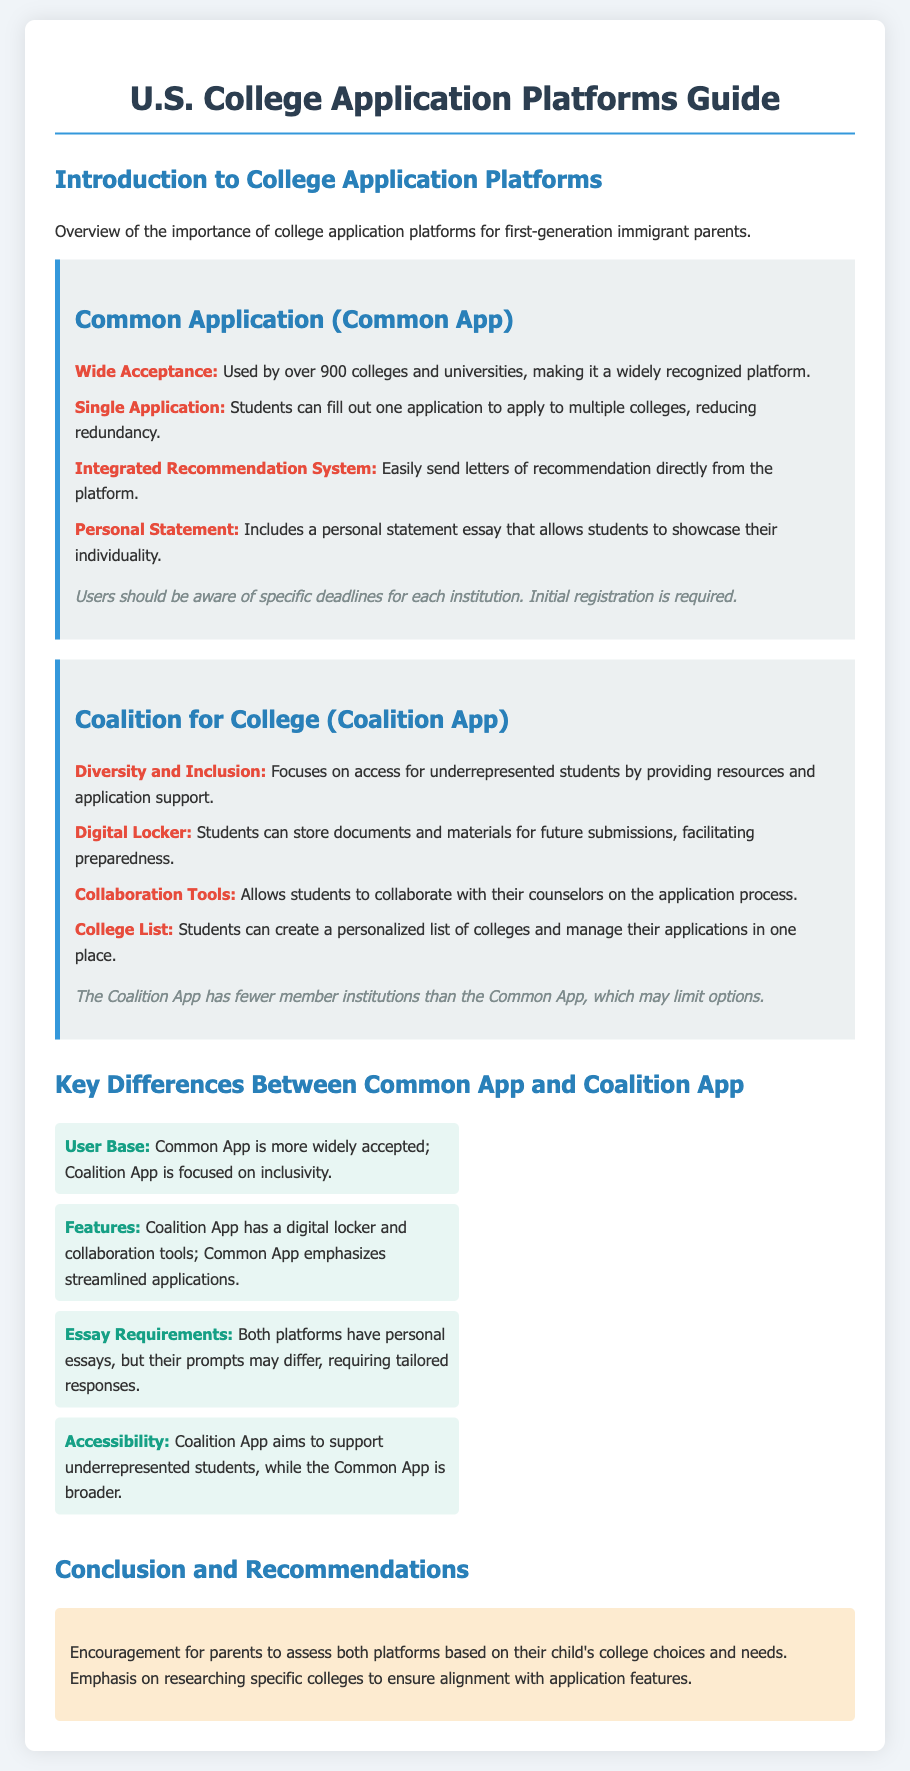What is the total number of colleges using the Common Application? The document states that the Common Application is used by over 900 colleges and universities.
Answer: over 900 What feature allows students to store documents for future submissions in the Coalition App? The document mentions a feature called "Digital Locker" that allows students to store documents.
Answer: Digital Locker Which application emphasizes collaboration with counselors during the application process? The Coalition App has a feature that allows students to collaborate with their counselors on the application process.
Answer: Coalition App What is the primary focus of the Coalition App? The Coalition App focuses on diversity and access for underrepresented students.
Answer: diversity and inclusion Which platform offers an integrated recommendation system? The Common Application includes an integrated recommendation system for sending letters of recommendation.
Answer: Common Application How does the Common App simplify the application process for multiple colleges? The document highlights that the Common App allows students to fill out one application to apply to multiple colleges, reducing redundancy.
Answer: Single Application What is one key difference in user base between the two application platforms? The Common App is more widely accepted compared to the Coalition App which is focused on inclusivity.
Answer: Common App is more widely accepted What type of statement is included in the Common App? The Common Application includes a personal statement essay that allows students to showcase their individuality.
Answer: personal statement What is one consideration mentioned for users of the Common Application? The document notes that users should be aware of specific deadlines for each institution when using the Common App.
Answer: specific deadlines 